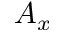Convert formula to latex. <formula><loc_0><loc_0><loc_500><loc_500>A _ { x }</formula> 